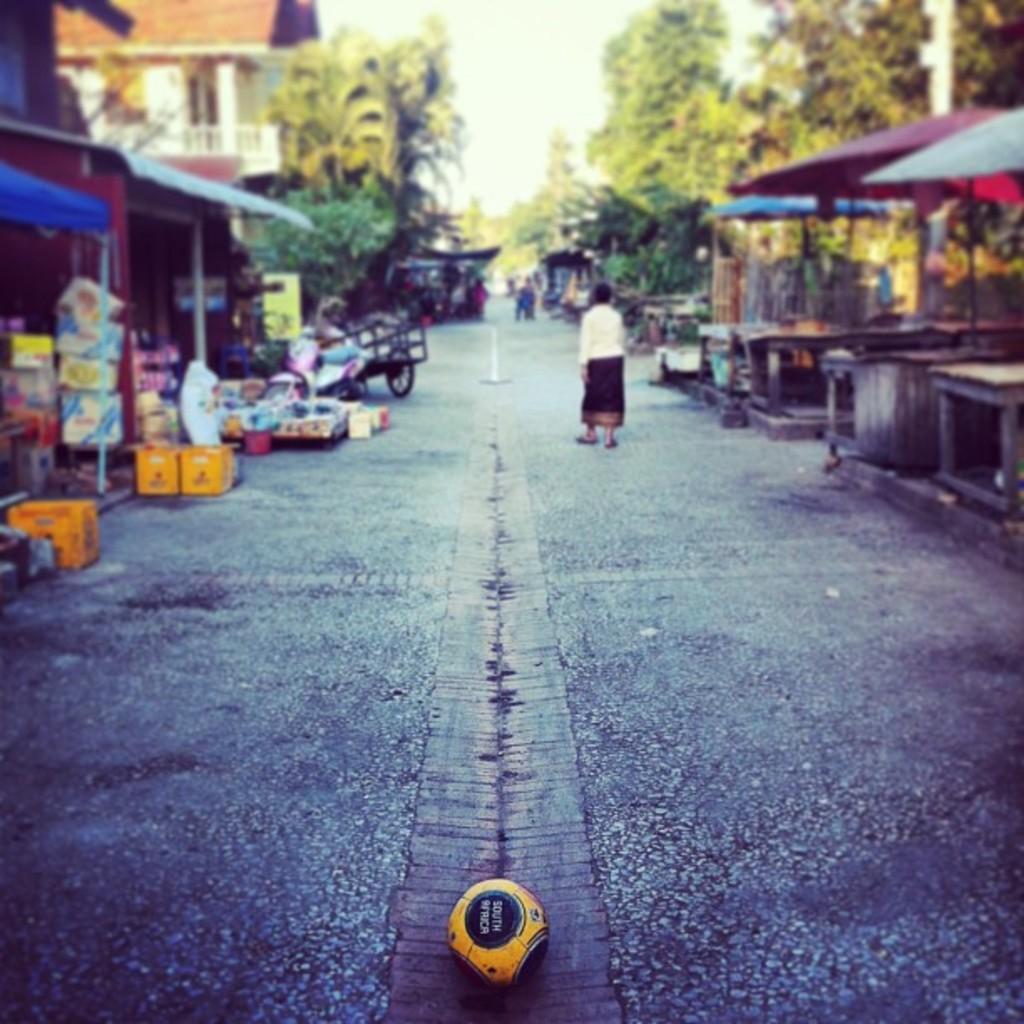Describe this image in one or two sentences. There is one person walking on the road as we can see at the bottom of this image. There are some trees and houses in the background. 